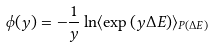Convert formula to latex. <formula><loc_0><loc_0><loc_500><loc_500>\phi ( y ) = - \frac { 1 } { y } \ln \langle \exp { ( y \Delta E ) } \rangle _ { P ( \Delta E ) }</formula> 